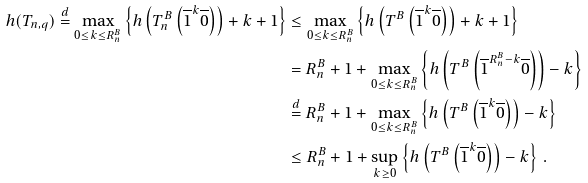<formula> <loc_0><loc_0><loc_500><loc_500>h ( T _ { n , q } ) \stackrel { d } { = } \max _ { 0 \leq k \leq R ^ { B } _ { n } } \left \{ h \left ( T ^ { B } _ { n } \left ( \overline { 1 } ^ { k } \overline { 0 } \right ) \right ) + k + 1 \right \} & \leq \max _ { 0 \leq k \leq R ^ { B } _ { n } } \left \{ h \left ( T ^ { B } \left ( \overline { 1 } ^ { k } \overline { 0 } \right ) \right ) + k + 1 \right \} \\ & = R ^ { B } _ { n } + 1 + \max _ { 0 \leq k \leq R ^ { B } _ { n } } \left \{ h \left ( T ^ { B } \left ( \overline { 1 } ^ { R ^ { B } _ { n } - k } \overline { 0 } \right ) \right ) - k \right \} \\ & \stackrel { d } { = } R ^ { B } _ { n } + 1 + \max _ { 0 \leq k \leq R ^ { B } _ { n } } \left \{ h \left ( T ^ { B } \left ( \overline { 1 } ^ { k } \overline { 0 } \right ) \right ) - k \right \} \\ & \leq R _ { n } ^ { B } + 1 + \sup _ { k \geq 0 } \left \{ h \left ( T ^ { B } \left ( \overline { 1 } ^ { k } \overline { 0 } \right ) \right ) - k \right \} \, .</formula> 